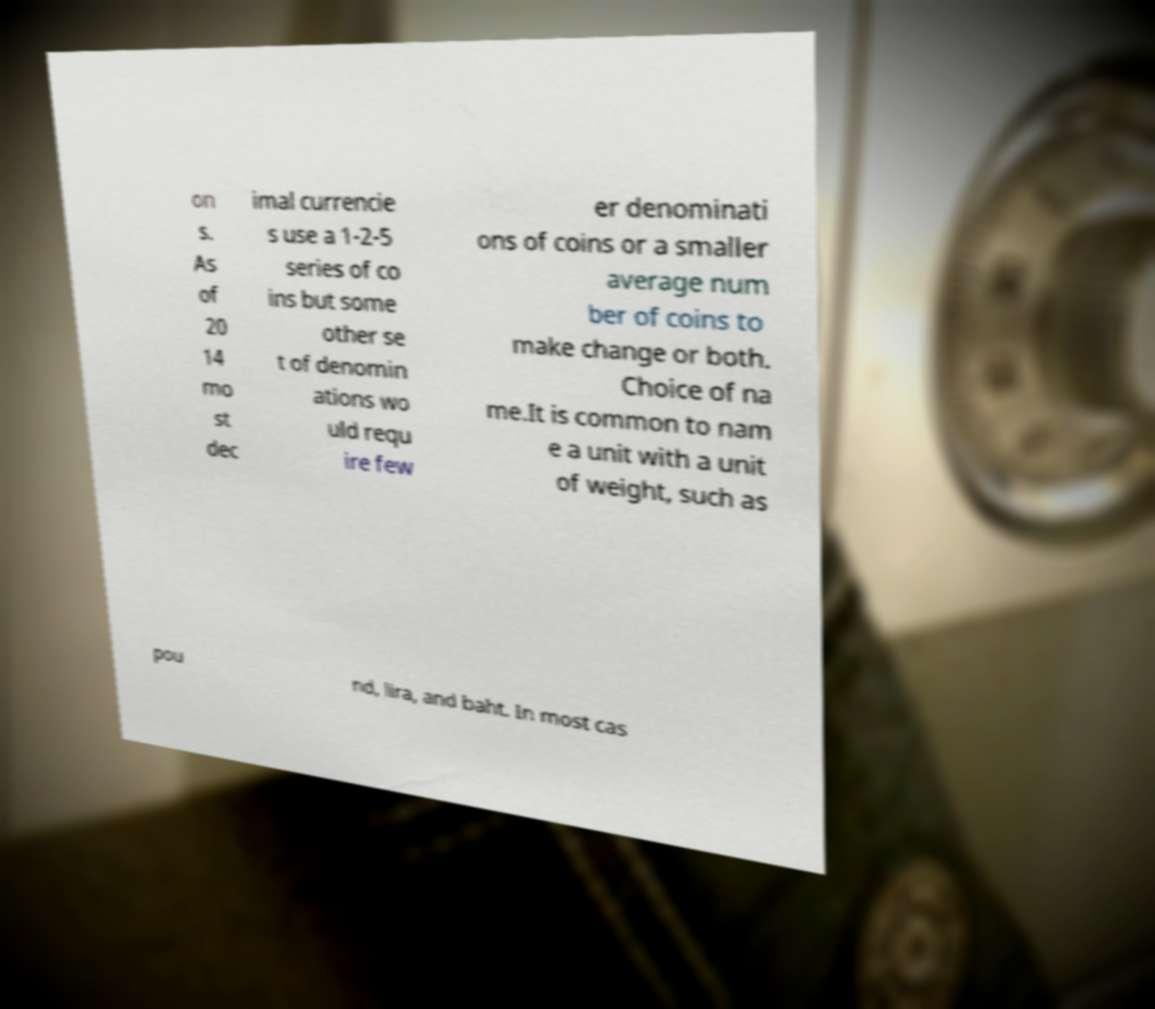For documentation purposes, I need the text within this image transcribed. Could you provide that? on s. As of 20 14 mo st dec imal currencie s use a 1-2-5 series of co ins but some other se t of denomin ations wo uld requ ire few er denominati ons of coins or a smaller average num ber of coins to make change or both. Choice of na me.It is common to nam e a unit with a unit of weight, such as pou nd, lira, and baht. In most cas 